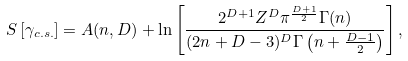<formula> <loc_0><loc_0><loc_500><loc_500>S \left [ \gamma _ { c . s . } \right ] = A ( n , D ) + \ln \left [ \frac { 2 ^ { D + 1 } Z ^ { D } \pi ^ { \frac { D + 1 } { 2 } } \Gamma ( n ) } { ( 2 n + D - 3 ) ^ { D } \Gamma \left ( n + \frac { D - 1 } { 2 } \right ) } \right ] ,</formula> 